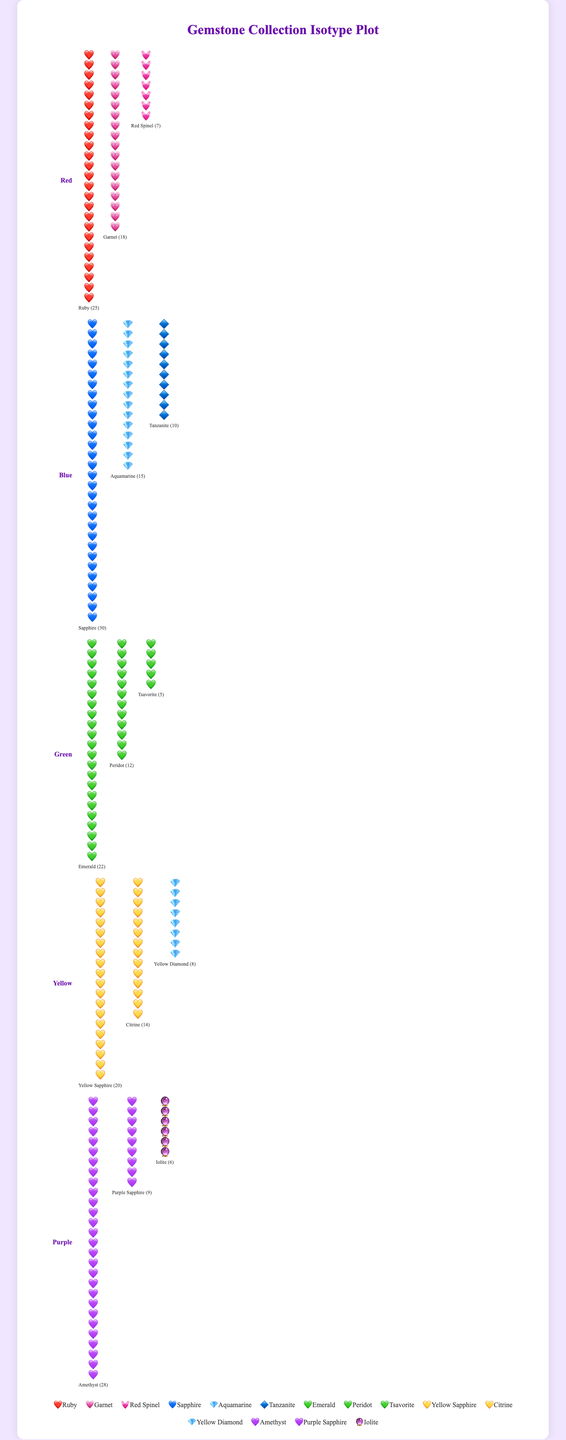How many types of purple gemstones are there? The plot shows three types of purple gemstones labeled with different names: Amethyst, Purple Sapphire, and Iolite.
Answer: 3 Which gemstone has the highest count in the Red category? By visually examining the icons and counts in the Red group, Ruby has a count of 25, which is the highest among all red gemstones.
Answer: Ruby What is the total number of gemstones in the Blue category? Add up the counts of Sapphires (30), Aquamarines (15), and Tanzanites (10). Total: 30 + 15 + 10 = 55.
Answer: 55 Is the count of Yellow Sapphires larger than the count of Citrines? Compare the counts of Yellow Sapphire (20) and Citrine (14). Yellow Sapphire has a higher count.
Answer: Yes Which color group has the highest total count of gemstones? Add the counts for each color group: 
Red: 25 + 18 + 7 = 50,
Blue: 30 + 15 + 10 = 55,
Green: 22 + 12 + 5 = 39,
Yellow: 20 + 14 + 8 = 42,
Purple: 28 + 9 + 6 = 43.
Blue group has the highest total count.
Answer: Blue How many more Emeralds are there compared to Peridots in the Green category? Subtract the number of Peridots (12) from Emeralds (22). 22 - 12 = 10.
Answer: 10 Which color group has the least variety of gemstone types? The number of gemstone types in each color group are: Red (3), Blue (3), Green (3), Yellow (3), Purple (3). All color groups have an equal variety of gemstone types.
Answer: All equal Is the count of Amethysts more than the combined count of Yellow Sapphires and Yellow Diamonds? Compare the count of Amethyst (28) with the sum of Yellow Sapphires (20) and Yellow Diamonds (8). 28 is equal to 20 + 8 = 28.
Answer: No What is the combined count of all Red and Purple gemstones? Sum the counts: 
Red (25 + 18 + 7 = 50),
Purple (28 + 9 + 6 = 43).
Total is 50 + 43 = 93.
Answer: 93 Which gemstone in the Blue category has the smallest count? The gemstones in the Blue category and their counts are: Sapphire (30), Aquamarine (15), Tanzanite (10). Tanzanite has the smallest count.
Answer: Tanzanite 